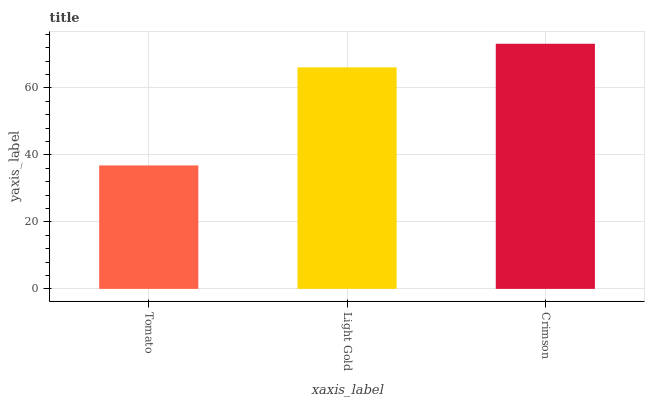Is Tomato the minimum?
Answer yes or no. Yes. Is Crimson the maximum?
Answer yes or no. Yes. Is Light Gold the minimum?
Answer yes or no. No. Is Light Gold the maximum?
Answer yes or no. No. Is Light Gold greater than Tomato?
Answer yes or no. Yes. Is Tomato less than Light Gold?
Answer yes or no. Yes. Is Tomato greater than Light Gold?
Answer yes or no. No. Is Light Gold less than Tomato?
Answer yes or no. No. Is Light Gold the high median?
Answer yes or no. Yes. Is Light Gold the low median?
Answer yes or no. Yes. Is Tomato the high median?
Answer yes or no. No. Is Crimson the low median?
Answer yes or no. No. 